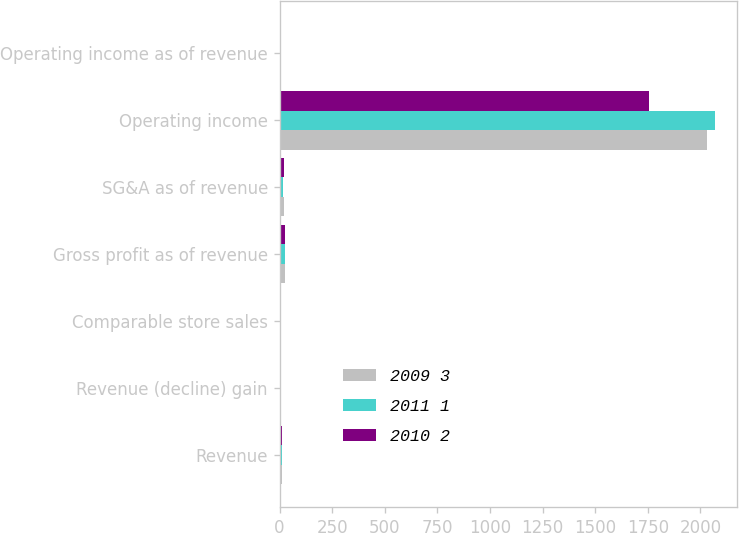Convert chart to OTSL. <chart><loc_0><loc_0><loc_500><loc_500><stacked_bar_chart><ecel><fcel>Revenue<fcel>Revenue (decline) gain<fcel>Comparable store sales<fcel>Gross profit as of revenue<fcel>SG&A as of revenue<fcel>Operating income<fcel>Operating income as of revenue<nl><fcel>2009 3<fcel>12.5<fcel>0.3<fcel>3<fcel>25.1<fcel>19.6<fcel>2031<fcel>5.5<nl><fcel>2011 1<fcel>12.5<fcel>6.4<fcel>1.7<fcel>24.2<fcel>18.6<fcel>2071<fcel>5.6<nl><fcel>2010 2<fcel>12.5<fcel>5.2<fcel>1.3<fcel>24.6<fcel>19.2<fcel>1758<fcel>5<nl></chart> 